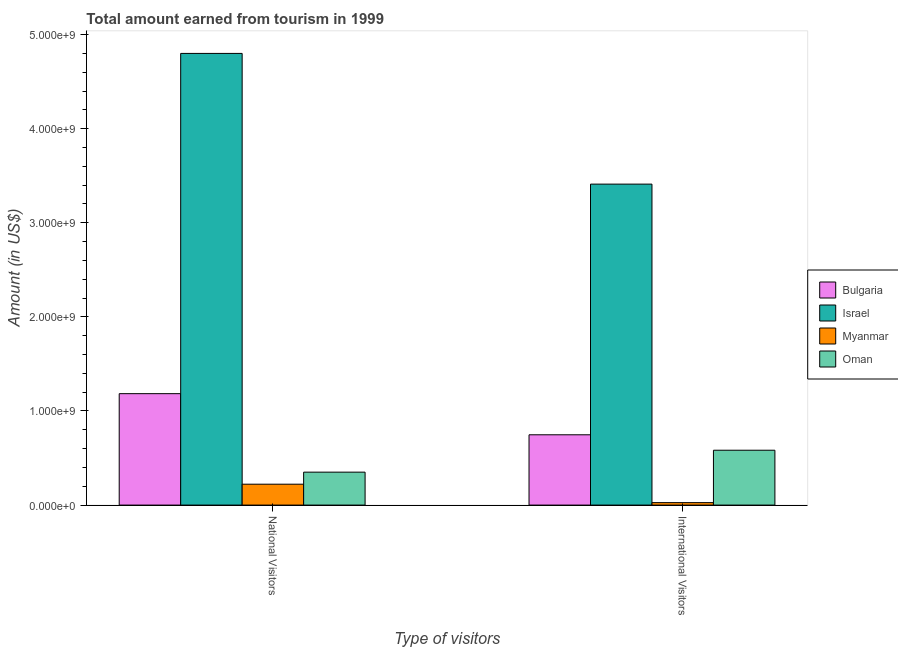How many groups of bars are there?
Your response must be concise. 2. Are the number of bars on each tick of the X-axis equal?
Your response must be concise. Yes. How many bars are there on the 2nd tick from the left?
Offer a terse response. 4. What is the label of the 2nd group of bars from the left?
Make the answer very short. International Visitors. What is the amount earned from national visitors in Myanmar?
Keep it short and to the point. 2.22e+08. Across all countries, what is the maximum amount earned from national visitors?
Offer a terse response. 4.80e+09. Across all countries, what is the minimum amount earned from national visitors?
Give a very brief answer. 2.22e+08. In which country was the amount earned from national visitors minimum?
Your answer should be compact. Myanmar. What is the total amount earned from national visitors in the graph?
Give a very brief answer. 6.56e+09. What is the difference between the amount earned from national visitors in Bulgaria and that in Israel?
Keep it short and to the point. -3.62e+09. What is the difference between the amount earned from international visitors in Israel and the amount earned from national visitors in Bulgaria?
Offer a very short reply. 2.23e+09. What is the average amount earned from international visitors per country?
Give a very brief answer. 1.19e+09. What is the difference between the amount earned from national visitors and amount earned from international visitors in Myanmar?
Give a very brief answer. 1.96e+08. What is the ratio of the amount earned from national visitors in Myanmar to that in Oman?
Give a very brief answer. 0.63. What does the 2nd bar from the left in National Visitors represents?
Make the answer very short. Israel. What does the 2nd bar from the right in International Visitors represents?
Provide a short and direct response. Myanmar. Are all the bars in the graph horizontal?
Offer a very short reply. No. Where does the legend appear in the graph?
Offer a terse response. Center right. What is the title of the graph?
Provide a short and direct response. Total amount earned from tourism in 1999. Does "Slovenia" appear as one of the legend labels in the graph?
Offer a terse response. No. What is the label or title of the X-axis?
Keep it short and to the point. Type of visitors. What is the label or title of the Y-axis?
Ensure brevity in your answer.  Amount (in US$). What is the Amount (in US$) in Bulgaria in National Visitors?
Make the answer very short. 1.18e+09. What is the Amount (in US$) of Israel in National Visitors?
Provide a succinct answer. 4.80e+09. What is the Amount (in US$) in Myanmar in National Visitors?
Make the answer very short. 2.22e+08. What is the Amount (in US$) of Oman in National Visitors?
Your answer should be compact. 3.50e+08. What is the Amount (in US$) of Bulgaria in International Visitors?
Make the answer very short. 7.47e+08. What is the Amount (in US$) of Israel in International Visitors?
Offer a terse response. 3.41e+09. What is the Amount (in US$) in Myanmar in International Visitors?
Ensure brevity in your answer.  2.60e+07. What is the Amount (in US$) in Oman in International Visitors?
Give a very brief answer. 5.83e+08. Across all Type of visitors, what is the maximum Amount (in US$) of Bulgaria?
Make the answer very short. 1.18e+09. Across all Type of visitors, what is the maximum Amount (in US$) of Israel?
Provide a short and direct response. 4.80e+09. Across all Type of visitors, what is the maximum Amount (in US$) in Myanmar?
Give a very brief answer. 2.22e+08. Across all Type of visitors, what is the maximum Amount (in US$) of Oman?
Offer a terse response. 5.83e+08. Across all Type of visitors, what is the minimum Amount (in US$) in Bulgaria?
Offer a terse response. 7.47e+08. Across all Type of visitors, what is the minimum Amount (in US$) of Israel?
Your answer should be compact. 3.41e+09. Across all Type of visitors, what is the minimum Amount (in US$) in Myanmar?
Your response must be concise. 2.60e+07. Across all Type of visitors, what is the minimum Amount (in US$) of Oman?
Provide a succinct answer. 3.50e+08. What is the total Amount (in US$) of Bulgaria in the graph?
Ensure brevity in your answer.  1.93e+09. What is the total Amount (in US$) of Israel in the graph?
Provide a short and direct response. 8.21e+09. What is the total Amount (in US$) in Myanmar in the graph?
Make the answer very short. 2.48e+08. What is the total Amount (in US$) of Oman in the graph?
Provide a succinct answer. 9.33e+08. What is the difference between the Amount (in US$) in Bulgaria in National Visitors and that in International Visitors?
Offer a terse response. 4.37e+08. What is the difference between the Amount (in US$) of Israel in National Visitors and that in International Visitors?
Make the answer very short. 1.39e+09. What is the difference between the Amount (in US$) of Myanmar in National Visitors and that in International Visitors?
Provide a succinct answer. 1.96e+08. What is the difference between the Amount (in US$) of Oman in National Visitors and that in International Visitors?
Keep it short and to the point. -2.33e+08. What is the difference between the Amount (in US$) of Bulgaria in National Visitors and the Amount (in US$) of Israel in International Visitors?
Offer a very short reply. -2.23e+09. What is the difference between the Amount (in US$) of Bulgaria in National Visitors and the Amount (in US$) of Myanmar in International Visitors?
Provide a short and direct response. 1.16e+09. What is the difference between the Amount (in US$) of Bulgaria in National Visitors and the Amount (in US$) of Oman in International Visitors?
Ensure brevity in your answer.  6.01e+08. What is the difference between the Amount (in US$) of Israel in National Visitors and the Amount (in US$) of Myanmar in International Visitors?
Offer a terse response. 4.77e+09. What is the difference between the Amount (in US$) of Israel in National Visitors and the Amount (in US$) of Oman in International Visitors?
Keep it short and to the point. 4.22e+09. What is the difference between the Amount (in US$) in Myanmar in National Visitors and the Amount (in US$) in Oman in International Visitors?
Provide a succinct answer. -3.61e+08. What is the average Amount (in US$) in Bulgaria per Type of visitors?
Provide a short and direct response. 9.66e+08. What is the average Amount (in US$) of Israel per Type of visitors?
Your response must be concise. 4.11e+09. What is the average Amount (in US$) in Myanmar per Type of visitors?
Make the answer very short. 1.24e+08. What is the average Amount (in US$) of Oman per Type of visitors?
Your response must be concise. 4.66e+08. What is the difference between the Amount (in US$) of Bulgaria and Amount (in US$) of Israel in National Visitors?
Your answer should be compact. -3.62e+09. What is the difference between the Amount (in US$) of Bulgaria and Amount (in US$) of Myanmar in National Visitors?
Keep it short and to the point. 9.62e+08. What is the difference between the Amount (in US$) of Bulgaria and Amount (in US$) of Oman in National Visitors?
Your response must be concise. 8.34e+08. What is the difference between the Amount (in US$) in Israel and Amount (in US$) in Myanmar in National Visitors?
Offer a very short reply. 4.58e+09. What is the difference between the Amount (in US$) of Israel and Amount (in US$) of Oman in National Visitors?
Offer a terse response. 4.45e+09. What is the difference between the Amount (in US$) in Myanmar and Amount (in US$) in Oman in National Visitors?
Your answer should be very brief. -1.28e+08. What is the difference between the Amount (in US$) in Bulgaria and Amount (in US$) in Israel in International Visitors?
Keep it short and to the point. -2.66e+09. What is the difference between the Amount (in US$) of Bulgaria and Amount (in US$) of Myanmar in International Visitors?
Your answer should be compact. 7.21e+08. What is the difference between the Amount (in US$) in Bulgaria and Amount (in US$) in Oman in International Visitors?
Your response must be concise. 1.64e+08. What is the difference between the Amount (in US$) of Israel and Amount (in US$) of Myanmar in International Visitors?
Your response must be concise. 3.38e+09. What is the difference between the Amount (in US$) of Israel and Amount (in US$) of Oman in International Visitors?
Provide a short and direct response. 2.83e+09. What is the difference between the Amount (in US$) of Myanmar and Amount (in US$) of Oman in International Visitors?
Provide a succinct answer. -5.57e+08. What is the ratio of the Amount (in US$) in Bulgaria in National Visitors to that in International Visitors?
Offer a very short reply. 1.58. What is the ratio of the Amount (in US$) of Israel in National Visitors to that in International Visitors?
Make the answer very short. 1.41. What is the ratio of the Amount (in US$) of Myanmar in National Visitors to that in International Visitors?
Your answer should be compact. 8.54. What is the ratio of the Amount (in US$) of Oman in National Visitors to that in International Visitors?
Provide a succinct answer. 0.6. What is the difference between the highest and the second highest Amount (in US$) in Bulgaria?
Give a very brief answer. 4.37e+08. What is the difference between the highest and the second highest Amount (in US$) in Israel?
Your answer should be very brief. 1.39e+09. What is the difference between the highest and the second highest Amount (in US$) in Myanmar?
Offer a very short reply. 1.96e+08. What is the difference between the highest and the second highest Amount (in US$) of Oman?
Offer a very short reply. 2.33e+08. What is the difference between the highest and the lowest Amount (in US$) in Bulgaria?
Give a very brief answer. 4.37e+08. What is the difference between the highest and the lowest Amount (in US$) of Israel?
Ensure brevity in your answer.  1.39e+09. What is the difference between the highest and the lowest Amount (in US$) of Myanmar?
Provide a short and direct response. 1.96e+08. What is the difference between the highest and the lowest Amount (in US$) in Oman?
Provide a short and direct response. 2.33e+08. 